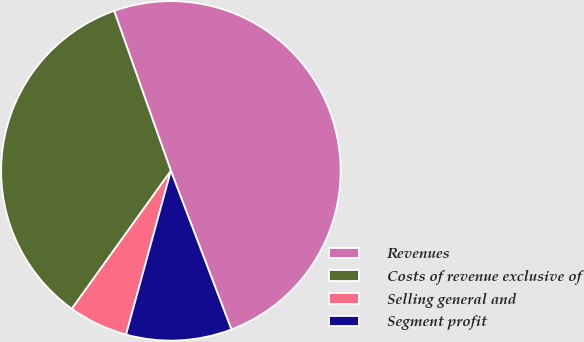<chart> <loc_0><loc_0><loc_500><loc_500><pie_chart><fcel>Revenues<fcel>Costs of revenue exclusive of<fcel>Selling general and<fcel>Segment profit<nl><fcel>49.62%<fcel>34.66%<fcel>5.66%<fcel>10.05%<nl></chart> 